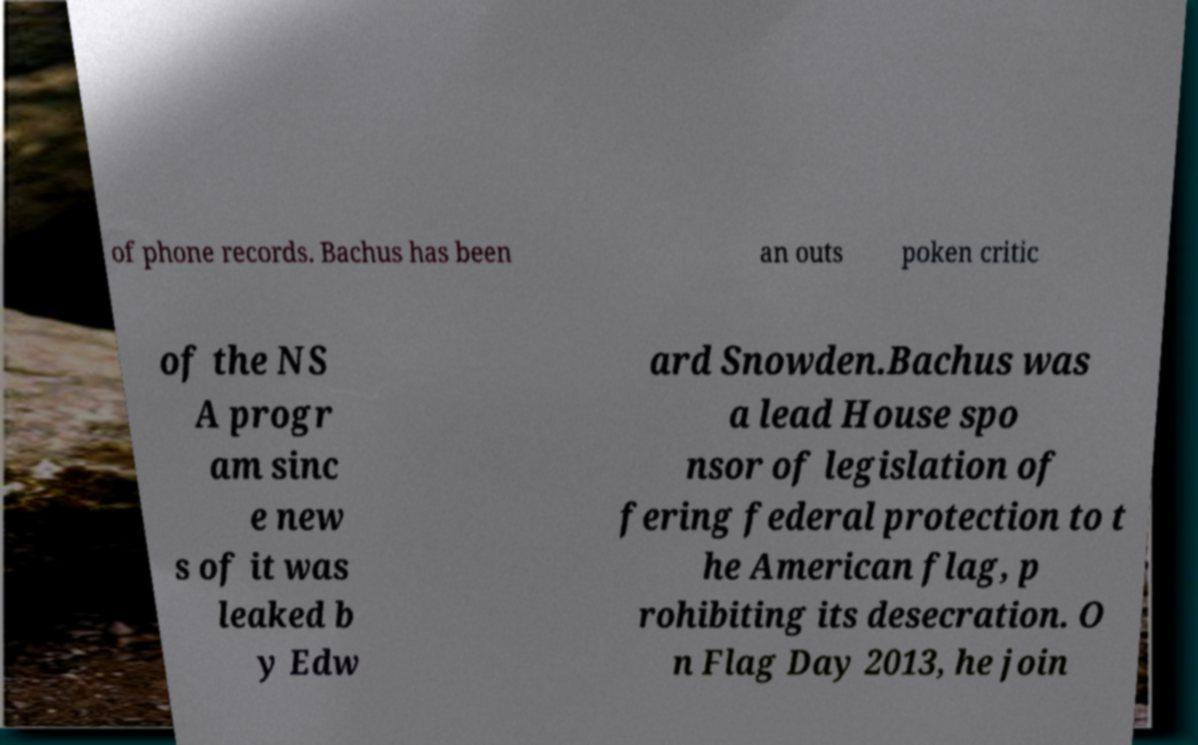Please identify and transcribe the text found in this image. of phone records. Bachus has been an outs poken critic of the NS A progr am sinc e new s of it was leaked b y Edw ard Snowden.Bachus was a lead House spo nsor of legislation of fering federal protection to t he American flag, p rohibiting its desecration. O n Flag Day 2013, he join 